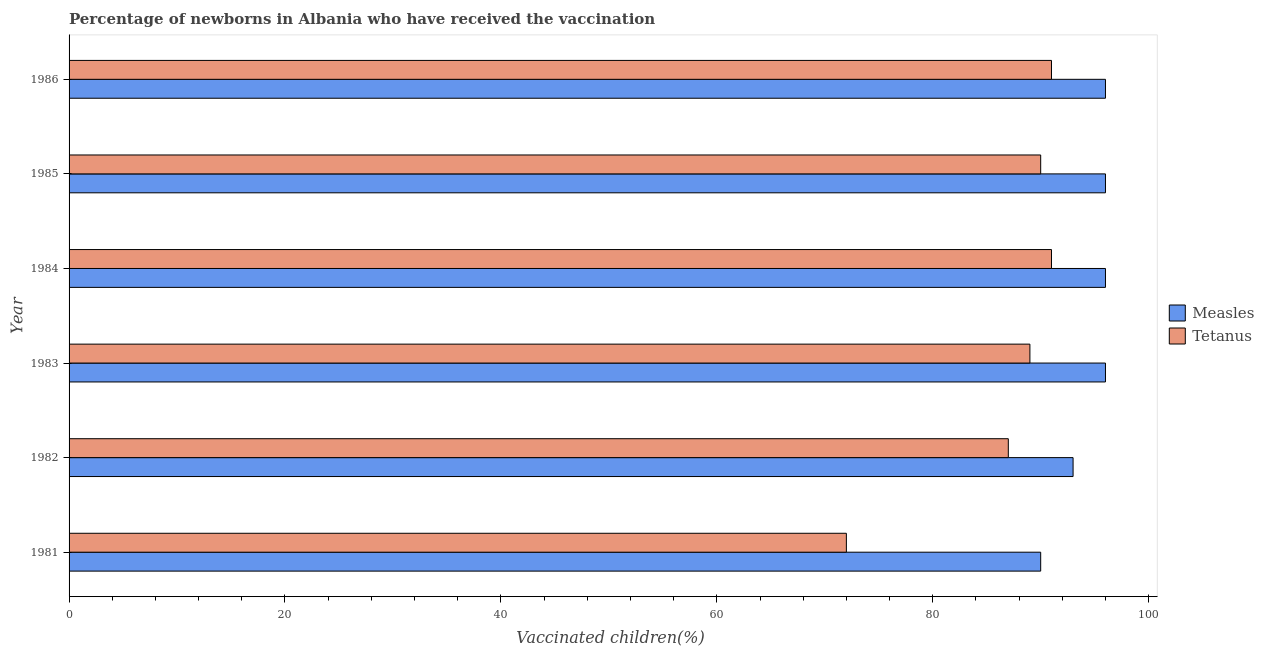How many groups of bars are there?
Make the answer very short. 6. Are the number of bars on each tick of the Y-axis equal?
Offer a terse response. Yes. How many bars are there on the 5th tick from the top?
Your answer should be compact. 2. In how many cases, is the number of bars for a given year not equal to the number of legend labels?
Your answer should be compact. 0. What is the percentage of newborns who received vaccination for tetanus in 1982?
Offer a very short reply. 87. Across all years, what is the maximum percentage of newborns who received vaccination for measles?
Your answer should be compact. 96. Across all years, what is the minimum percentage of newborns who received vaccination for measles?
Give a very brief answer. 90. In which year was the percentage of newborns who received vaccination for measles maximum?
Offer a terse response. 1983. What is the total percentage of newborns who received vaccination for measles in the graph?
Provide a succinct answer. 567. What is the difference between the percentage of newborns who received vaccination for tetanus in 1981 and that in 1985?
Your answer should be very brief. -18. What is the difference between the percentage of newborns who received vaccination for tetanus in 1984 and the percentage of newborns who received vaccination for measles in 1981?
Provide a succinct answer. 1. What is the average percentage of newborns who received vaccination for measles per year?
Your answer should be very brief. 94.5. In the year 1982, what is the difference between the percentage of newborns who received vaccination for tetanus and percentage of newborns who received vaccination for measles?
Provide a succinct answer. -6. What is the ratio of the percentage of newborns who received vaccination for tetanus in 1981 to that in 1983?
Keep it short and to the point. 0.81. Is the percentage of newborns who received vaccination for measles in 1985 less than that in 1986?
Offer a very short reply. No. Is the difference between the percentage of newborns who received vaccination for measles in 1981 and 1984 greater than the difference between the percentage of newborns who received vaccination for tetanus in 1981 and 1984?
Provide a short and direct response. Yes. What is the difference between the highest and the lowest percentage of newborns who received vaccination for tetanus?
Your answer should be very brief. 19. In how many years, is the percentage of newborns who received vaccination for tetanus greater than the average percentage of newborns who received vaccination for tetanus taken over all years?
Offer a terse response. 5. What does the 2nd bar from the top in 1986 represents?
Provide a short and direct response. Measles. What does the 1st bar from the bottom in 1983 represents?
Offer a terse response. Measles. How many bars are there?
Offer a very short reply. 12. How many years are there in the graph?
Offer a very short reply. 6. Are the values on the major ticks of X-axis written in scientific E-notation?
Provide a succinct answer. No. Does the graph contain any zero values?
Your answer should be compact. No. Where does the legend appear in the graph?
Give a very brief answer. Center right. How many legend labels are there?
Provide a succinct answer. 2. How are the legend labels stacked?
Make the answer very short. Vertical. What is the title of the graph?
Give a very brief answer. Percentage of newborns in Albania who have received the vaccination. Does "Agricultural land" appear as one of the legend labels in the graph?
Your response must be concise. No. What is the label or title of the X-axis?
Keep it short and to the point. Vaccinated children(%)
. What is the label or title of the Y-axis?
Ensure brevity in your answer.  Year. What is the Vaccinated children(%)
 of Measles in 1981?
Offer a terse response. 90. What is the Vaccinated children(%)
 of Measles in 1982?
Ensure brevity in your answer.  93. What is the Vaccinated children(%)
 of Measles in 1983?
Give a very brief answer. 96. What is the Vaccinated children(%)
 in Tetanus in 1983?
Offer a terse response. 89. What is the Vaccinated children(%)
 of Measles in 1984?
Ensure brevity in your answer.  96. What is the Vaccinated children(%)
 of Tetanus in 1984?
Keep it short and to the point. 91. What is the Vaccinated children(%)
 in Measles in 1985?
Keep it short and to the point. 96. What is the Vaccinated children(%)
 of Tetanus in 1985?
Offer a terse response. 90. What is the Vaccinated children(%)
 in Measles in 1986?
Give a very brief answer. 96. What is the Vaccinated children(%)
 in Tetanus in 1986?
Keep it short and to the point. 91. Across all years, what is the maximum Vaccinated children(%)
 of Measles?
Your response must be concise. 96. Across all years, what is the maximum Vaccinated children(%)
 in Tetanus?
Your answer should be compact. 91. Across all years, what is the minimum Vaccinated children(%)
 in Tetanus?
Keep it short and to the point. 72. What is the total Vaccinated children(%)
 of Measles in the graph?
Your response must be concise. 567. What is the total Vaccinated children(%)
 of Tetanus in the graph?
Ensure brevity in your answer.  520. What is the difference between the Vaccinated children(%)
 of Tetanus in 1981 and that in 1983?
Make the answer very short. -17. What is the difference between the Vaccinated children(%)
 of Measles in 1981 and that in 1984?
Provide a succinct answer. -6. What is the difference between the Vaccinated children(%)
 in Measles in 1981 and that in 1985?
Your answer should be compact. -6. What is the difference between the Vaccinated children(%)
 of Measles in 1982 and that in 1984?
Ensure brevity in your answer.  -3. What is the difference between the Vaccinated children(%)
 of Measles in 1982 and that in 1985?
Provide a succinct answer. -3. What is the difference between the Vaccinated children(%)
 of Tetanus in 1982 and that in 1985?
Keep it short and to the point. -3. What is the difference between the Vaccinated children(%)
 of Measles in 1982 and that in 1986?
Offer a very short reply. -3. What is the difference between the Vaccinated children(%)
 of Tetanus in 1983 and that in 1984?
Make the answer very short. -2. What is the difference between the Vaccinated children(%)
 of Measles in 1983 and that in 1985?
Your answer should be very brief. 0. What is the difference between the Vaccinated children(%)
 in Tetanus in 1983 and that in 1985?
Your answer should be compact. -1. What is the difference between the Vaccinated children(%)
 in Measles in 1983 and that in 1986?
Your response must be concise. 0. What is the difference between the Vaccinated children(%)
 in Tetanus in 1983 and that in 1986?
Ensure brevity in your answer.  -2. What is the difference between the Vaccinated children(%)
 in Tetanus in 1984 and that in 1986?
Make the answer very short. 0. What is the difference between the Vaccinated children(%)
 in Tetanus in 1985 and that in 1986?
Your answer should be compact. -1. What is the difference between the Vaccinated children(%)
 of Measles in 1981 and the Vaccinated children(%)
 of Tetanus in 1982?
Provide a short and direct response. 3. What is the difference between the Vaccinated children(%)
 of Measles in 1981 and the Vaccinated children(%)
 of Tetanus in 1984?
Offer a terse response. -1. What is the difference between the Vaccinated children(%)
 in Measles in 1981 and the Vaccinated children(%)
 in Tetanus in 1986?
Your response must be concise. -1. What is the difference between the Vaccinated children(%)
 of Measles in 1982 and the Vaccinated children(%)
 of Tetanus in 1984?
Provide a succinct answer. 2. What is the difference between the Vaccinated children(%)
 of Measles in 1982 and the Vaccinated children(%)
 of Tetanus in 1985?
Make the answer very short. 3. What is the difference between the Vaccinated children(%)
 of Measles in 1982 and the Vaccinated children(%)
 of Tetanus in 1986?
Offer a very short reply. 2. What is the difference between the Vaccinated children(%)
 in Measles in 1984 and the Vaccinated children(%)
 in Tetanus in 1985?
Offer a very short reply. 6. What is the difference between the Vaccinated children(%)
 of Measles in 1984 and the Vaccinated children(%)
 of Tetanus in 1986?
Provide a succinct answer. 5. What is the difference between the Vaccinated children(%)
 of Measles in 1985 and the Vaccinated children(%)
 of Tetanus in 1986?
Provide a short and direct response. 5. What is the average Vaccinated children(%)
 of Measles per year?
Make the answer very short. 94.5. What is the average Vaccinated children(%)
 of Tetanus per year?
Ensure brevity in your answer.  86.67. In the year 1981, what is the difference between the Vaccinated children(%)
 of Measles and Vaccinated children(%)
 of Tetanus?
Provide a succinct answer. 18. In the year 1982, what is the difference between the Vaccinated children(%)
 in Measles and Vaccinated children(%)
 in Tetanus?
Keep it short and to the point. 6. In the year 1983, what is the difference between the Vaccinated children(%)
 of Measles and Vaccinated children(%)
 of Tetanus?
Your response must be concise. 7. In the year 1984, what is the difference between the Vaccinated children(%)
 of Measles and Vaccinated children(%)
 of Tetanus?
Your answer should be compact. 5. What is the ratio of the Vaccinated children(%)
 of Tetanus in 1981 to that in 1982?
Offer a very short reply. 0.83. What is the ratio of the Vaccinated children(%)
 of Tetanus in 1981 to that in 1983?
Your response must be concise. 0.81. What is the ratio of the Vaccinated children(%)
 of Measles in 1981 to that in 1984?
Provide a succinct answer. 0.94. What is the ratio of the Vaccinated children(%)
 of Tetanus in 1981 to that in 1984?
Make the answer very short. 0.79. What is the ratio of the Vaccinated children(%)
 of Measles in 1981 to that in 1986?
Give a very brief answer. 0.94. What is the ratio of the Vaccinated children(%)
 in Tetanus in 1981 to that in 1986?
Your response must be concise. 0.79. What is the ratio of the Vaccinated children(%)
 of Measles in 1982 to that in 1983?
Give a very brief answer. 0.97. What is the ratio of the Vaccinated children(%)
 of Tetanus in 1982 to that in 1983?
Ensure brevity in your answer.  0.98. What is the ratio of the Vaccinated children(%)
 of Measles in 1982 to that in 1984?
Make the answer very short. 0.97. What is the ratio of the Vaccinated children(%)
 of Tetanus in 1982 to that in 1984?
Offer a terse response. 0.96. What is the ratio of the Vaccinated children(%)
 of Measles in 1982 to that in 1985?
Give a very brief answer. 0.97. What is the ratio of the Vaccinated children(%)
 of Tetanus in 1982 to that in 1985?
Your answer should be very brief. 0.97. What is the ratio of the Vaccinated children(%)
 in Measles in 1982 to that in 1986?
Offer a terse response. 0.97. What is the ratio of the Vaccinated children(%)
 of Tetanus in 1982 to that in 1986?
Make the answer very short. 0.96. What is the ratio of the Vaccinated children(%)
 in Measles in 1983 to that in 1985?
Offer a terse response. 1. What is the ratio of the Vaccinated children(%)
 in Tetanus in 1983 to that in 1985?
Make the answer very short. 0.99. What is the ratio of the Vaccinated children(%)
 in Measles in 1983 to that in 1986?
Provide a short and direct response. 1. What is the ratio of the Vaccinated children(%)
 in Measles in 1984 to that in 1985?
Your answer should be compact. 1. What is the ratio of the Vaccinated children(%)
 of Tetanus in 1984 to that in 1985?
Your response must be concise. 1.01. What is the ratio of the Vaccinated children(%)
 in Measles in 1984 to that in 1986?
Give a very brief answer. 1. What is the ratio of the Vaccinated children(%)
 in Tetanus in 1984 to that in 1986?
Provide a short and direct response. 1. What is the ratio of the Vaccinated children(%)
 of Measles in 1985 to that in 1986?
Your response must be concise. 1. What is the difference between the highest and the second highest Vaccinated children(%)
 of Measles?
Provide a succinct answer. 0. What is the difference between the highest and the lowest Vaccinated children(%)
 in Measles?
Provide a succinct answer. 6. 